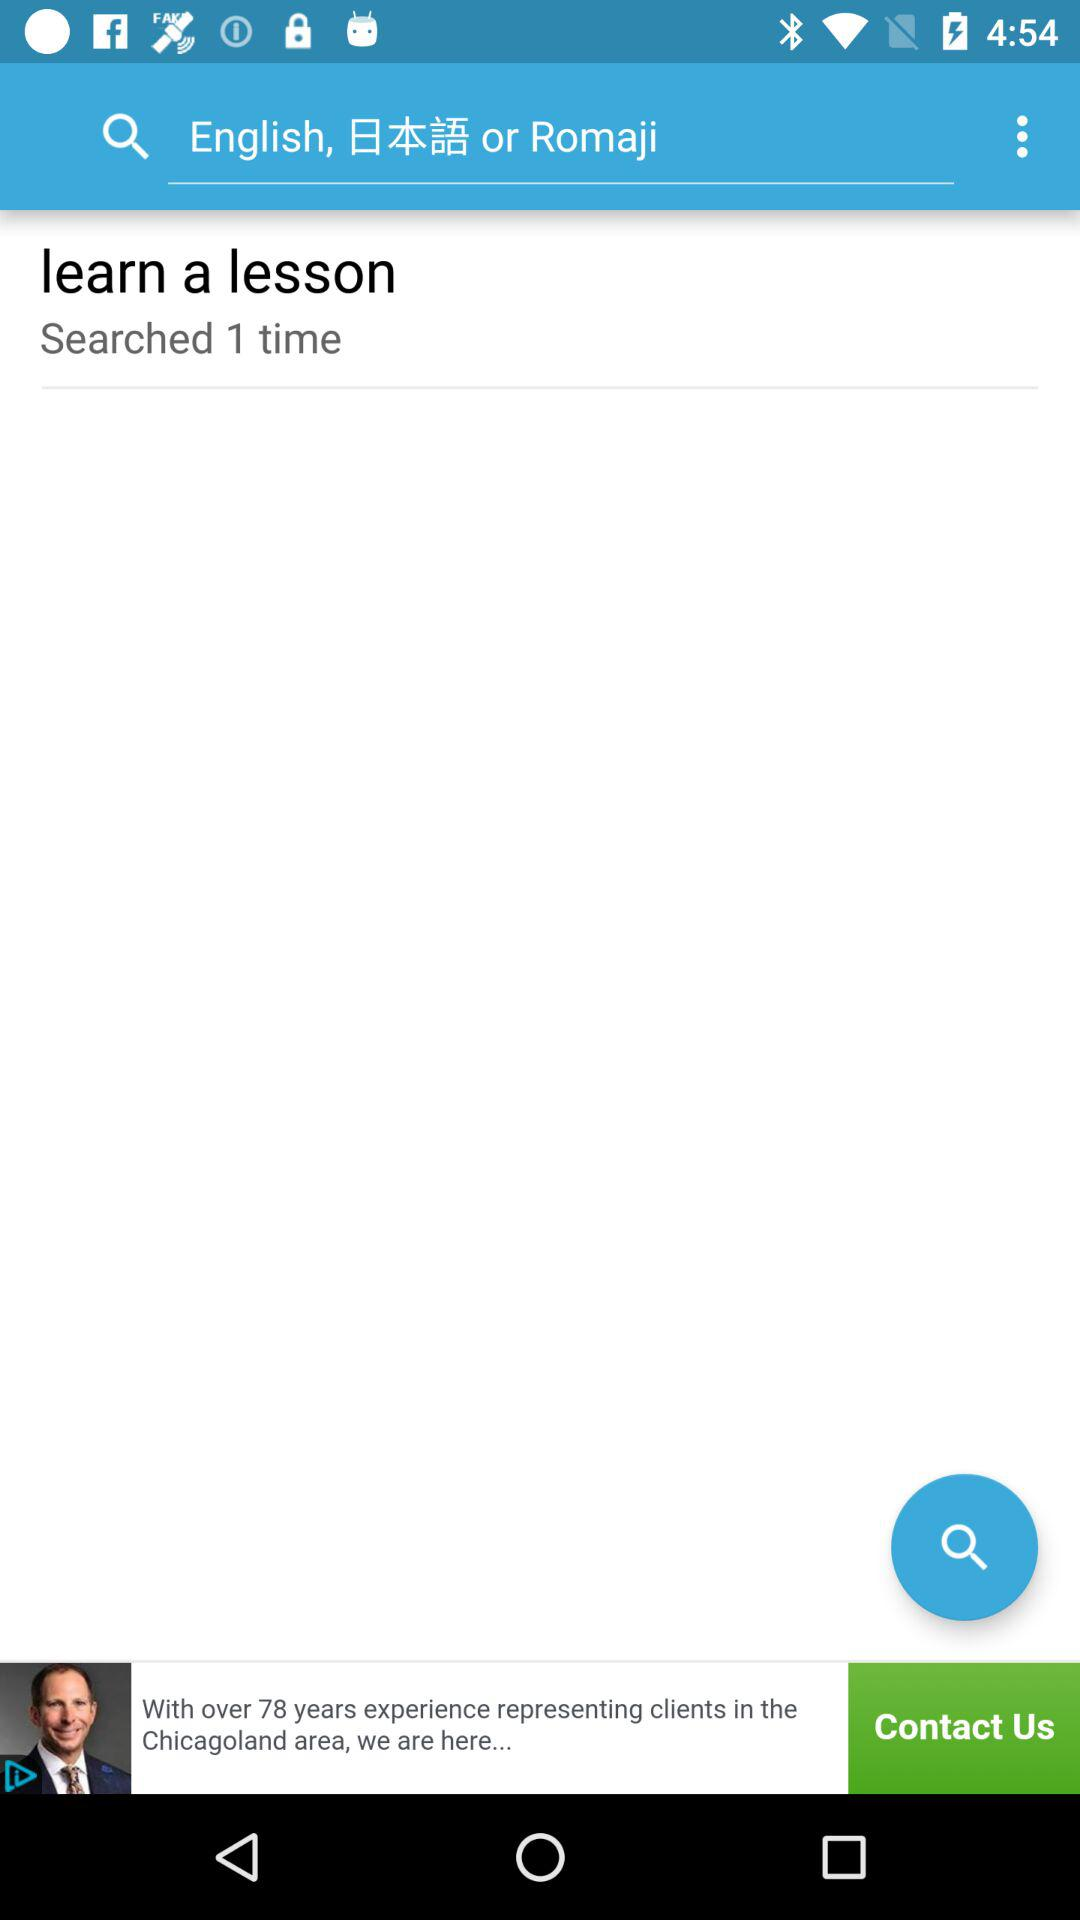How many times "learn a lesson" is searched? Learn a lesson was searched 1 time. 